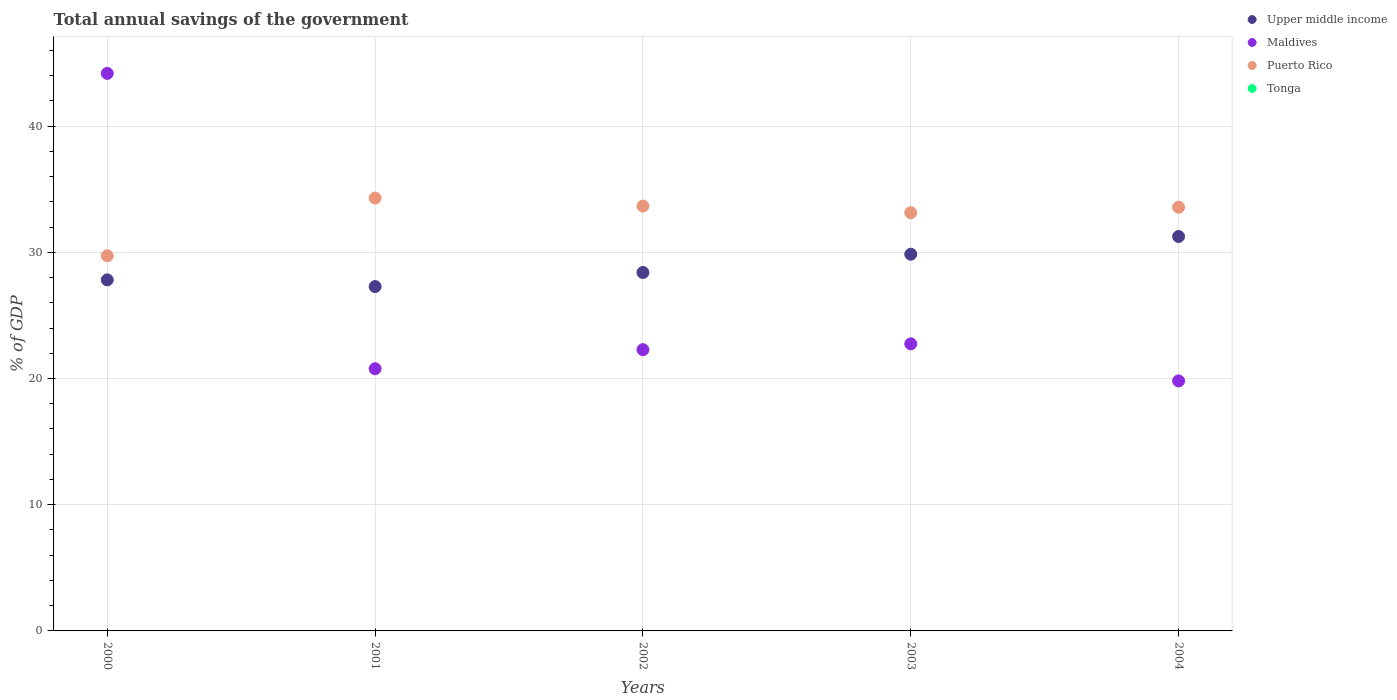What is the total annual savings of the government in Maldives in 2002?
Offer a very short reply. 22.29. Across all years, what is the maximum total annual savings of the government in Puerto Rico?
Your response must be concise. 34.3. What is the total total annual savings of the government in Puerto Rico in the graph?
Provide a succinct answer. 164.4. What is the difference between the total annual savings of the government in Upper middle income in 2001 and that in 2004?
Keep it short and to the point. -3.97. What is the difference between the total annual savings of the government in Puerto Rico in 2004 and the total annual savings of the government in Maldives in 2000?
Your answer should be very brief. -10.61. In the year 2000, what is the difference between the total annual savings of the government in Maldives and total annual savings of the government in Puerto Rico?
Offer a very short reply. 14.45. What is the ratio of the total annual savings of the government in Maldives in 2003 to that in 2004?
Make the answer very short. 1.15. What is the difference between the highest and the second highest total annual savings of the government in Puerto Rico?
Ensure brevity in your answer.  0.63. What is the difference between the highest and the lowest total annual savings of the government in Upper middle income?
Your response must be concise. 3.97. Is the sum of the total annual savings of the government in Puerto Rico in 2001 and 2004 greater than the maximum total annual savings of the government in Upper middle income across all years?
Offer a very short reply. Yes. Is it the case that in every year, the sum of the total annual savings of the government in Maldives and total annual savings of the government in Puerto Rico  is greater than the sum of total annual savings of the government in Upper middle income and total annual savings of the government in Tonga?
Give a very brief answer. No. Is the total annual savings of the government in Maldives strictly greater than the total annual savings of the government in Puerto Rico over the years?
Offer a terse response. No. Is the total annual savings of the government in Puerto Rico strictly less than the total annual savings of the government in Maldives over the years?
Make the answer very short. No. How many years are there in the graph?
Your answer should be very brief. 5. Does the graph contain grids?
Ensure brevity in your answer.  Yes. How many legend labels are there?
Keep it short and to the point. 4. What is the title of the graph?
Offer a terse response. Total annual savings of the government. What is the label or title of the X-axis?
Give a very brief answer. Years. What is the label or title of the Y-axis?
Keep it short and to the point. % of GDP. What is the % of GDP of Upper middle income in 2000?
Give a very brief answer. 27.82. What is the % of GDP in Maldives in 2000?
Make the answer very short. 44.18. What is the % of GDP in Puerto Rico in 2000?
Your answer should be compact. 29.72. What is the % of GDP of Tonga in 2000?
Ensure brevity in your answer.  0. What is the % of GDP in Upper middle income in 2001?
Your response must be concise. 27.28. What is the % of GDP in Maldives in 2001?
Offer a terse response. 20.78. What is the % of GDP of Puerto Rico in 2001?
Give a very brief answer. 34.3. What is the % of GDP in Upper middle income in 2002?
Make the answer very short. 28.4. What is the % of GDP in Maldives in 2002?
Your answer should be very brief. 22.29. What is the % of GDP in Puerto Rico in 2002?
Offer a terse response. 33.66. What is the % of GDP in Upper middle income in 2003?
Your response must be concise. 29.85. What is the % of GDP of Maldives in 2003?
Give a very brief answer. 22.75. What is the % of GDP in Puerto Rico in 2003?
Ensure brevity in your answer.  33.14. What is the % of GDP of Tonga in 2003?
Give a very brief answer. 0. What is the % of GDP of Upper middle income in 2004?
Make the answer very short. 31.25. What is the % of GDP in Maldives in 2004?
Your answer should be compact. 19.81. What is the % of GDP in Puerto Rico in 2004?
Your answer should be compact. 33.57. What is the % of GDP of Tonga in 2004?
Make the answer very short. 0. Across all years, what is the maximum % of GDP of Upper middle income?
Ensure brevity in your answer.  31.25. Across all years, what is the maximum % of GDP of Maldives?
Offer a very short reply. 44.18. Across all years, what is the maximum % of GDP in Puerto Rico?
Ensure brevity in your answer.  34.3. Across all years, what is the minimum % of GDP of Upper middle income?
Keep it short and to the point. 27.28. Across all years, what is the minimum % of GDP of Maldives?
Ensure brevity in your answer.  19.81. Across all years, what is the minimum % of GDP in Puerto Rico?
Provide a succinct answer. 29.72. What is the total % of GDP of Upper middle income in the graph?
Your response must be concise. 144.6. What is the total % of GDP of Maldives in the graph?
Offer a very short reply. 129.8. What is the total % of GDP in Puerto Rico in the graph?
Give a very brief answer. 164.4. What is the total % of GDP of Tonga in the graph?
Offer a very short reply. 0. What is the difference between the % of GDP in Upper middle income in 2000 and that in 2001?
Keep it short and to the point. 0.53. What is the difference between the % of GDP in Maldives in 2000 and that in 2001?
Your answer should be compact. 23.4. What is the difference between the % of GDP in Puerto Rico in 2000 and that in 2001?
Your answer should be compact. -4.57. What is the difference between the % of GDP in Upper middle income in 2000 and that in 2002?
Your response must be concise. -0.59. What is the difference between the % of GDP in Maldives in 2000 and that in 2002?
Make the answer very short. 21.89. What is the difference between the % of GDP of Puerto Rico in 2000 and that in 2002?
Keep it short and to the point. -3.94. What is the difference between the % of GDP in Upper middle income in 2000 and that in 2003?
Make the answer very short. -2.03. What is the difference between the % of GDP of Maldives in 2000 and that in 2003?
Keep it short and to the point. 21.43. What is the difference between the % of GDP in Puerto Rico in 2000 and that in 2003?
Make the answer very short. -3.41. What is the difference between the % of GDP in Upper middle income in 2000 and that in 2004?
Make the answer very short. -3.44. What is the difference between the % of GDP in Maldives in 2000 and that in 2004?
Your answer should be compact. 24.37. What is the difference between the % of GDP in Puerto Rico in 2000 and that in 2004?
Ensure brevity in your answer.  -3.85. What is the difference between the % of GDP of Upper middle income in 2001 and that in 2002?
Offer a terse response. -1.12. What is the difference between the % of GDP in Maldives in 2001 and that in 2002?
Make the answer very short. -1.51. What is the difference between the % of GDP of Puerto Rico in 2001 and that in 2002?
Give a very brief answer. 0.63. What is the difference between the % of GDP in Upper middle income in 2001 and that in 2003?
Your answer should be very brief. -2.56. What is the difference between the % of GDP of Maldives in 2001 and that in 2003?
Give a very brief answer. -1.97. What is the difference between the % of GDP in Puerto Rico in 2001 and that in 2003?
Provide a short and direct response. 1.16. What is the difference between the % of GDP of Upper middle income in 2001 and that in 2004?
Offer a very short reply. -3.97. What is the difference between the % of GDP in Maldives in 2001 and that in 2004?
Your answer should be very brief. 0.97. What is the difference between the % of GDP of Puerto Rico in 2001 and that in 2004?
Provide a succinct answer. 0.73. What is the difference between the % of GDP of Upper middle income in 2002 and that in 2003?
Keep it short and to the point. -1.45. What is the difference between the % of GDP of Maldives in 2002 and that in 2003?
Offer a very short reply. -0.46. What is the difference between the % of GDP of Puerto Rico in 2002 and that in 2003?
Offer a terse response. 0.53. What is the difference between the % of GDP of Upper middle income in 2002 and that in 2004?
Give a very brief answer. -2.85. What is the difference between the % of GDP of Maldives in 2002 and that in 2004?
Provide a succinct answer. 2.48. What is the difference between the % of GDP in Puerto Rico in 2002 and that in 2004?
Provide a succinct answer. 0.09. What is the difference between the % of GDP of Upper middle income in 2003 and that in 2004?
Ensure brevity in your answer.  -1.4. What is the difference between the % of GDP of Maldives in 2003 and that in 2004?
Ensure brevity in your answer.  2.94. What is the difference between the % of GDP of Puerto Rico in 2003 and that in 2004?
Your answer should be compact. -0.43. What is the difference between the % of GDP in Upper middle income in 2000 and the % of GDP in Maldives in 2001?
Your response must be concise. 7.04. What is the difference between the % of GDP in Upper middle income in 2000 and the % of GDP in Puerto Rico in 2001?
Ensure brevity in your answer.  -6.48. What is the difference between the % of GDP in Maldives in 2000 and the % of GDP in Puerto Rico in 2001?
Ensure brevity in your answer.  9.88. What is the difference between the % of GDP in Upper middle income in 2000 and the % of GDP in Maldives in 2002?
Provide a succinct answer. 5.53. What is the difference between the % of GDP of Upper middle income in 2000 and the % of GDP of Puerto Rico in 2002?
Provide a succinct answer. -5.85. What is the difference between the % of GDP in Maldives in 2000 and the % of GDP in Puerto Rico in 2002?
Your answer should be very brief. 10.51. What is the difference between the % of GDP in Upper middle income in 2000 and the % of GDP in Maldives in 2003?
Ensure brevity in your answer.  5.07. What is the difference between the % of GDP of Upper middle income in 2000 and the % of GDP of Puerto Rico in 2003?
Your response must be concise. -5.32. What is the difference between the % of GDP of Maldives in 2000 and the % of GDP of Puerto Rico in 2003?
Provide a short and direct response. 11.04. What is the difference between the % of GDP in Upper middle income in 2000 and the % of GDP in Maldives in 2004?
Ensure brevity in your answer.  8.01. What is the difference between the % of GDP of Upper middle income in 2000 and the % of GDP of Puerto Rico in 2004?
Offer a very short reply. -5.76. What is the difference between the % of GDP of Maldives in 2000 and the % of GDP of Puerto Rico in 2004?
Give a very brief answer. 10.61. What is the difference between the % of GDP of Upper middle income in 2001 and the % of GDP of Maldives in 2002?
Give a very brief answer. 5. What is the difference between the % of GDP in Upper middle income in 2001 and the % of GDP in Puerto Rico in 2002?
Offer a very short reply. -6.38. What is the difference between the % of GDP of Maldives in 2001 and the % of GDP of Puerto Rico in 2002?
Offer a very short reply. -12.89. What is the difference between the % of GDP in Upper middle income in 2001 and the % of GDP in Maldives in 2003?
Provide a short and direct response. 4.54. What is the difference between the % of GDP in Upper middle income in 2001 and the % of GDP in Puerto Rico in 2003?
Give a very brief answer. -5.85. What is the difference between the % of GDP of Maldives in 2001 and the % of GDP of Puerto Rico in 2003?
Your answer should be very brief. -12.36. What is the difference between the % of GDP of Upper middle income in 2001 and the % of GDP of Maldives in 2004?
Ensure brevity in your answer.  7.47. What is the difference between the % of GDP of Upper middle income in 2001 and the % of GDP of Puerto Rico in 2004?
Offer a very short reply. -6.29. What is the difference between the % of GDP in Maldives in 2001 and the % of GDP in Puerto Rico in 2004?
Offer a very short reply. -12.8. What is the difference between the % of GDP in Upper middle income in 2002 and the % of GDP in Maldives in 2003?
Your answer should be compact. 5.66. What is the difference between the % of GDP in Upper middle income in 2002 and the % of GDP in Puerto Rico in 2003?
Make the answer very short. -4.74. What is the difference between the % of GDP in Maldives in 2002 and the % of GDP in Puerto Rico in 2003?
Your answer should be very brief. -10.85. What is the difference between the % of GDP of Upper middle income in 2002 and the % of GDP of Maldives in 2004?
Make the answer very short. 8.59. What is the difference between the % of GDP in Upper middle income in 2002 and the % of GDP in Puerto Rico in 2004?
Offer a very short reply. -5.17. What is the difference between the % of GDP in Maldives in 2002 and the % of GDP in Puerto Rico in 2004?
Keep it short and to the point. -11.29. What is the difference between the % of GDP of Upper middle income in 2003 and the % of GDP of Maldives in 2004?
Ensure brevity in your answer.  10.04. What is the difference between the % of GDP of Upper middle income in 2003 and the % of GDP of Puerto Rico in 2004?
Give a very brief answer. -3.72. What is the difference between the % of GDP in Maldives in 2003 and the % of GDP in Puerto Rico in 2004?
Ensure brevity in your answer.  -10.83. What is the average % of GDP of Upper middle income per year?
Make the answer very short. 28.92. What is the average % of GDP in Maldives per year?
Your response must be concise. 25.96. What is the average % of GDP of Puerto Rico per year?
Your answer should be very brief. 32.88. In the year 2000, what is the difference between the % of GDP of Upper middle income and % of GDP of Maldives?
Offer a terse response. -16.36. In the year 2000, what is the difference between the % of GDP of Upper middle income and % of GDP of Puerto Rico?
Your answer should be very brief. -1.91. In the year 2000, what is the difference between the % of GDP of Maldives and % of GDP of Puerto Rico?
Your answer should be very brief. 14.45. In the year 2001, what is the difference between the % of GDP of Upper middle income and % of GDP of Maldives?
Ensure brevity in your answer.  6.51. In the year 2001, what is the difference between the % of GDP in Upper middle income and % of GDP in Puerto Rico?
Provide a succinct answer. -7.01. In the year 2001, what is the difference between the % of GDP in Maldives and % of GDP in Puerto Rico?
Offer a very short reply. -13.52. In the year 2002, what is the difference between the % of GDP in Upper middle income and % of GDP in Maldives?
Keep it short and to the point. 6.12. In the year 2002, what is the difference between the % of GDP in Upper middle income and % of GDP in Puerto Rico?
Your response must be concise. -5.26. In the year 2002, what is the difference between the % of GDP in Maldives and % of GDP in Puerto Rico?
Your answer should be very brief. -11.38. In the year 2003, what is the difference between the % of GDP of Upper middle income and % of GDP of Maldives?
Offer a very short reply. 7.1. In the year 2003, what is the difference between the % of GDP in Upper middle income and % of GDP in Puerto Rico?
Offer a very short reply. -3.29. In the year 2003, what is the difference between the % of GDP in Maldives and % of GDP in Puerto Rico?
Offer a terse response. -10.39. In the year 2004, what is the difference between the % of GDP of Upper middle income and % of GDP of Maldives?
Offer a terse response. 11.44. In the year 2004, what is the difference between the % of GDP of Upper middle income and % of GDP of Puerto Rico?
Give a very brief answer. -2.32. In the year 2004, what is the difference between the % of GDP in Maldives and % of GDP in Puerto Rico?
Provide a succinct answer. -13.76. What is the ratio of the % of GDP in Upper middle income in 2000 to that in 2001?
Provide a succinct answer. 1.02. What is the ratio of the % of GDP of Maldives in 2000 to that in 2001?
Your response must be concise. 2.13. What is the ratio of the % of GDP in Puerto Rico in 2000 to that in 2001?
Your answer should be compact. 0.87. What is the ratio of the % of GDP of Upper middle income in 2000 to that in 2002?
Provide a succinct answer. 0.98. What is the ratio of the % of GDP in Maldives in 2000 to that in 2002?
Offer a terse response. 1.98. What is the ratio of the % of GDP of Puerto Rico in 2000 to that in 2002?
Give a very brief answer. 0.88. What is the ratio of the % of GDP of Upper middle income in 2000 to that in 2003?
Your answer should be very brief. 0.93. What is the ratio of the % of GDP of Maldives in 2000 to that in 2003?
Provide a succinct answer. 1.94. What is the ratio of the % of GDP of Puerto Rico in 2000 to that in 2003?
Provide a succinct answer. 0.9. What is the ratio of the % of GDP of Upper middle income in 2000 to that in 2004?
Make the answer very short. 0.89. What is the ratio of the % of GDP of Maldives in 2000 to that in 2004?
Ensure brevity in your answer.  2.23. What is the ratio of the % of GDP in Puerto Rico in 2000 to that in 2004?
Your response must be concise. 0.89. What is the ratio of the % of GDP of Upper middle income in 2001 to that in 2002?
Your answer should be very brief. 0.96. What is the ratio of the % of GDP of Maldives in 2001 to that in 2002?
Keep it short and to the point. 0.93. What is the ratio of the % of GDP of Puerto Rico in 2001 to that in 2002?
Keep it short and to the point. 1.02. What is the ratio of the % of GDP of Upper middle income in 2001 to that in 2003?
Keep it short and to the point. 0.91. What is the ratio of the % of GDP in Maldives in 2001 to that in 2003?
Your answer should be very brief. 0.91. What is the ratio of the % of GDP in Puerto Rico in 2001 to that in 2003?
Your response must be concise. 1.03. What is the ratio of the % of GDP in Upper middle income in 2001 to that in 2004?
Give a very brief answer. 0.87. What is the ratio of the % of GDP of Maldives in 2001 to that in 2004?
Keep it short and to the point. 1.05. What is the ratio of the % of GDP in Puerto Rico in 2001 to that in 2004?
Give a very brief answer. 1.02. What is the ratio of the % of GDP of Upper middle income in 2002 to that in 2003?
Keep it short and to the point. 0.95. What is the ratio of the % of GDP of Maldives in 2002 to that in 2003?
Offer a terse response. 0.98. What is the ratio of the % of GDP in Puerto Rico in 2002 to that in 2003?
Make the answer very short. 1.02. What is the ratio of the % of GDP in Upper middle income in 2002 to that in 2004?
Your answer should be very brief. 0.91. What is the ratio of the % of GDP in Maldives in 2002 to that in 2004?
Offer a very short reply. 1.12. What is the ratio of the % of GDP in Upper middle income in 2003 to that in 2004?
Ensure brevity in your answer.  0.95. What is the ratio of the % of GDP in Maldives in 2003 to that in 2004?
Give a very brief answer. 1.15. What is the ratio of the % of GDP in Puerto Rico in 2003 to that in 2004?
Make the answer very short. 0.99. What is the difference between the highest and the second highest % of GDP of Upper middle income?
Keep it short and to the point. 1.4. What is the difference between the highest and the second highest % of GDP of Maldives?
Give a very brief answer. 21.43. What is the difference between the highest and the second highest % of GDP of Puerto Rico?
Ensure brevity in your answer.  0.63. What is the difference between the highest and the lowest % of GDP of Upper middle income?
Provide a short and direct response. 3.97. What is the difference between the highest and the lowest % of GDP of Maldives?
Your response must be concise. 24.37. What is the difference between the highest and the lowest % of GDP of Puerto Rico?
Ensure brevity in your answer.  4.57. 